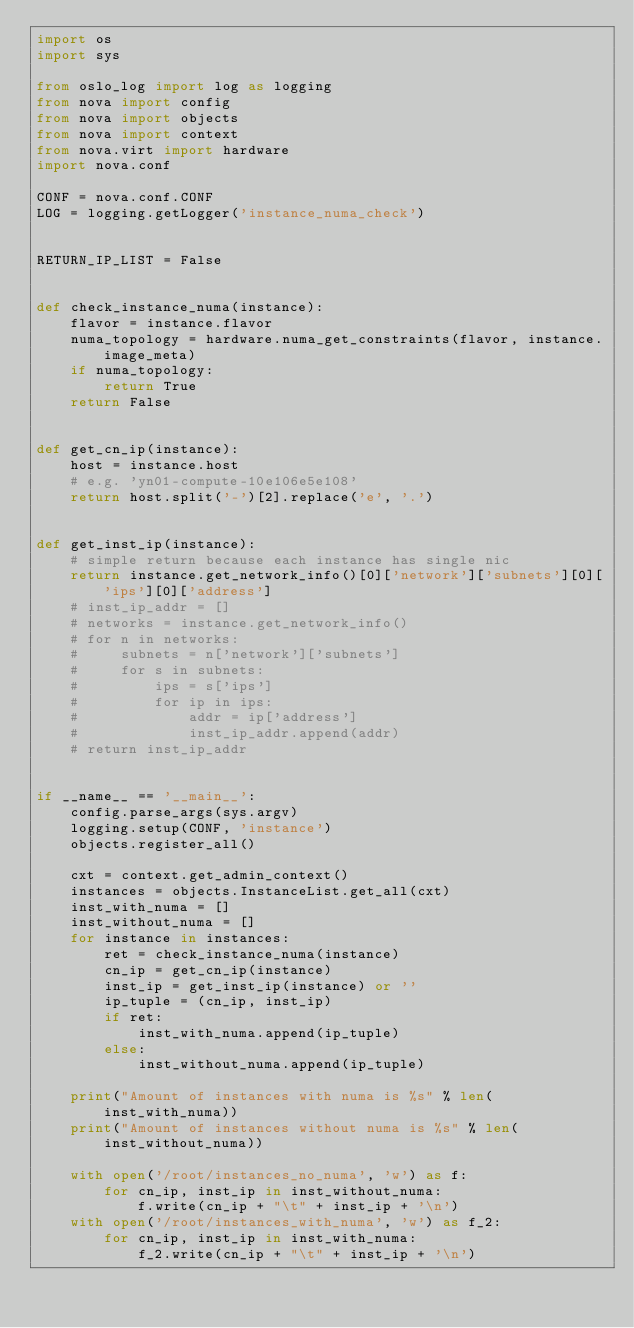Convert code to text. <code><loc_0><loc_0><loc_500><loc_500><_Python_>import os
import sys

from oslo_log import log as logging
from nova import config
from nova import objects
from nova import context
from nova.virt import hardware
import nova.conf

CONF = nova.conf.CONF
LOG = logging.getLogger('instance_numa_check')


RETURN_IP_LIST = False


def check_instance_numa(instance):
    flavor = instance.flavor
    numa_topology = hardware.numa_get_constraints(flavor, instance.image_meta)
    if numa_topology:
        return True
    return False


def get_cn_ip(instance):
    host = instance.host
    # e.g. 'yn01-compute-10e106e5e108'
    return host.split('-')[2].replace('e', '.')


def get_inst_ip(instance):
    # simple return because each instance has single nic
    return instance.get_network_info()[0]['network']['subnets'][0]['ips'][0]['address']
    # inst_ip_addr = []
    # networks = instance.get_network_info()
    # for n in networks:
    #     subnets = n['network']['subnets']
    #     for s in subnets:
    #         ips = s['ips']
    #         for ip in ips:
    #             addr = ip['address']
    #             inst_ip_addr.append(addr)
    # return inst_ip_addr


if __name__ == '__main__':
    config.parse_args(sys.argv)
    logging.setup(CONF, 'instance')
    objects.register_all()

    cxt = context.get_admin_context()
    instances = objects.InstanceList.get_all(cxt)
    inst_with_numa = []
    inst_without_numa = []
    for instance in instances:
        ret = check_instance_numa(instance)
        cn_ip = get_cn_ip(instance)
        inst_ip = get_inst_ip(instance) or ''
        ip_tuple = (cn_ip, inst_ip)
        if ret:
            inst_with_numa.append(ip_tuple)
        else:
            inst_without_numa.append(ip_tuple)

    print("Amount of instances with numa is %s" % len(inst_with_numa))
    print("Amount of instances without numa is %s" % len(inst_without_numa))

    with open('/root/instances_no_numa', 'w') as f:
        for cn_ip, inst_ip in inst_without_numa:
            f.write(cn_ip + "\t" + inst_ip + '\n')
    with open('/root/instances_with_numa', 'w') as f_2:
        for cn_ip, inst_ip in inst_with_numa:
            f_2.write(cn_ip + "\t" + inst_ip + '\n')
</code> 